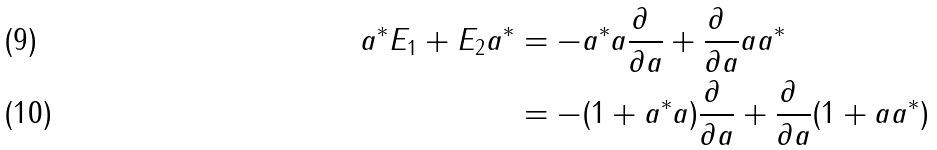<formula> <loc_0><loc_0><loc_500><loc_500>a ^ { \ast } E _ { 1 } + E _ { 2 } a ^ { \ast } & = - a ^ { \ast } a \frac { \partial \ } { \partial a } + \frac { \partial \ } { \partial a } a a ^ { \ast } \\ & = - ( 1 + a ^ { \ast } a ) \frac { \partial \ } { \partial a } + \frac { \partial \ } { \partial a } ( 1 + a a ^ { \ast } )</formula> 